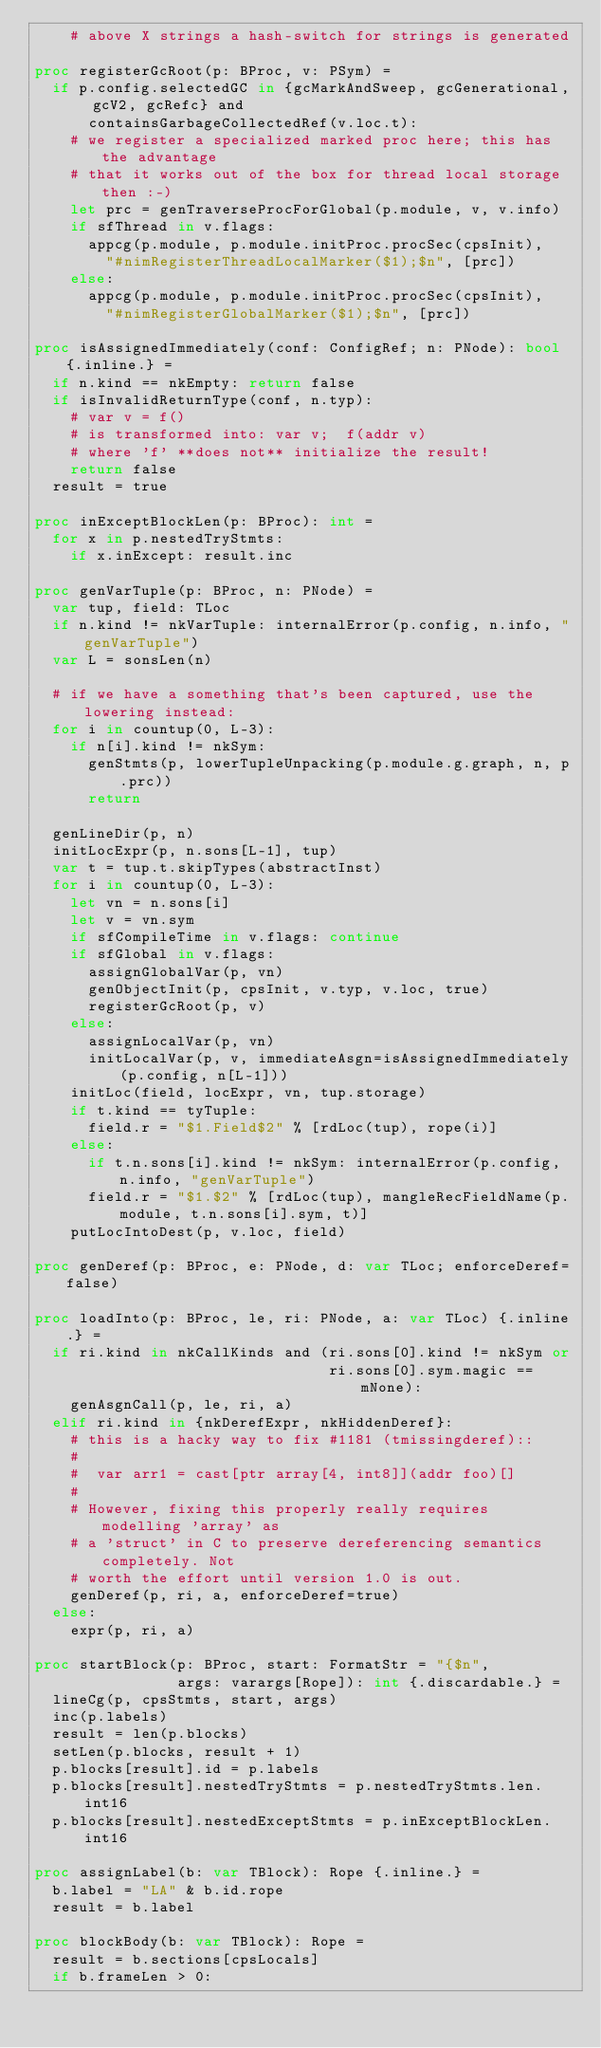<code> <loc_0><loc_0><loc_500><loc_500><_Nim_>    # above X strings a hash-switch for strings is generated

proc registerGcRoot(p: BProc, v: PSym) =
  if p.config.selectedGC in {gcMarkAndSweep, gcGenerational, gcV2, gcRefc} and
      containsGarbageCollectedRef(v.loc.t):
    # we register a specialized marked proc here; this has the advantage
    # that it works out of the box for thread local storage then :-)
    let prc = genTraverseProcForGlobal(p.module, v, v.info)
    if sfThread in v.flags:
      appcg(p.module, p.module.initProc.procSec(cpsInit),
        "#nimRegisterThreadLocalMarker($1);$n", [prc])
    else:
      appcg(p.module, p.module.initProc.procSec(cpsInit),
        "#nimRegisterGlobalMarker($1);$n", [prc])

proc isAssignedImmediately(conf: ConfigRef; n: PNode): bool {.inline.} =
  if n.kind == nkEmpty: return false
  if isInvalidReturnType(conf, n.typ):
    # var v = f()
    # is transformed into: var v;  f(addr v)
    # where 'f' **does not** initialize the result!
    return false
  result = true

proc inExceptBlockLen(p: BProc): int =
  for x in p.nestedTryStmts:
    if x.inExcept: result.inc

proc genVarTuple(p: BProc, n: PNode) =
  var tup, field: TLoc
  if n.kind != nkVarTuple: internalError(p.config, n.info, "genVarTuple")
  var L = sonsLen(n)

  # if we have a something that's been captured, use the lowering instead:
  for i in countup(0, L-3):
    if n[i].kind != nkSym:
      genStmts(p, lowerTupleUnpacking(p.module.g.graph, n, p.prc))
      return

  genLineDir(p, n)
  initLocExpr(p, n.sons[L-1], tup)
  var t = tup.t.skipTypes(abstractInst)
  for i in countup(0, L-3):
    let vn = n.sons[i]
    let v = vn.sym
    if sfCompileTime in v.flags: continue
    if sfGlobal in v.flags:
      assignGlobalVar(p, vn)
      genObjectInit(p, cpsInit, v.typ, v.loc, true)
      registerGcRoot(p, v)
    else:
      assignLocalVar(p, vn)
      initLocalVar(p, v, immediateAsgn=isAssignedImmediately(p.config, n[L-1]))
    initLoc(field, locExpr, vn, tup.storage)
    if t.kind == tyTuple:
      field.r = "$1.Field$2" % [rdLoc(tup), rope(i)]
    else:
      if t.n.sons[i].kind != nkSym: internalError(p.config, n.info, "genVarTuple")
      field.r = "$1.$2" % [rdLoc(tup), mangleRecFieldName(p.module, t.n.sons[i].sym, t)]
    putLocIntoDest(p, v.loc, field)

proc genDeref(p: BProc, e: PNode, d: var TLoc; enforceDeref=false)

proc loadInto(p: BProc, le, ri: PNode, a: var TLoc) {.inline.} =
  if ri.kind in nkCallKinds and (ri.sons[0].kind != nkSym or
                                 ri.sons[0].sym.magic == mNone):
    genAsgnCall(p, le, ri, a)
  elif ri.kind in {nkDerefExpr, nkHiddenDeref}:
    # this is a hacky way to fix #1181 (tmissingderef)::
    #
    #  var arr1 = cast[ptr array[4, int8]](addr foo)[]
    #
    # However, fixing this properly really requires modelling 'array' as
    # a 'struct' in C to preserve dereferencing semantics completely. Not
    # worth the effort until version 1.0 is out.
    genDeref(p, ri, a, enforceDeref=true)
  else:
    expr(p, ri, a)

proc startBlock(p: BProc, start: FormatStr = "{$n",
                args: varargs[Rope]): int {.discardable.} =
  lineCg(p, cpsStmts, start, args)
  inc(p.labels)
  result = len(p.blocks)
  setLen(p.blocks, result + 1)
  p.blocks[result].id = p.labels
  p.blocks[result].nestedTryStmts = p.nestedTryStmts.len.int16
  p.blocks[result].nestedExceptStmts = p.inExceptBlockLen.int16

proc assignLabel(b: var TBlock): Rope {.inline.} =
  b.label = "LA" & b.id.rope
  result = b.label

proc blockBody(b: var TBlock): Rope =
  result = b.sections[cpsLocals]
  if b.frameLen > 0:</code> 